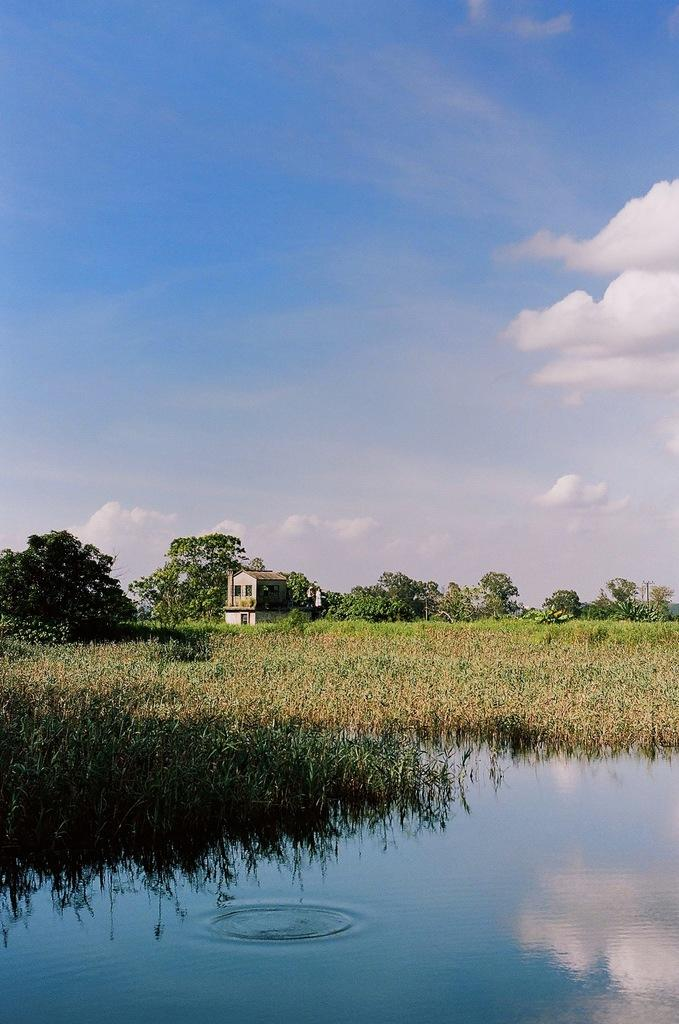What is present at the bottom of the image? There is water at the bottom of the image. What can be seen in the background of the image? There are trees, plants, and a building in the background of the image. What is visible in the sky in the image? There are clouds in the sky. How many sisters are sitting on the invention in the image? There are no sisters or inventions present in the image. 